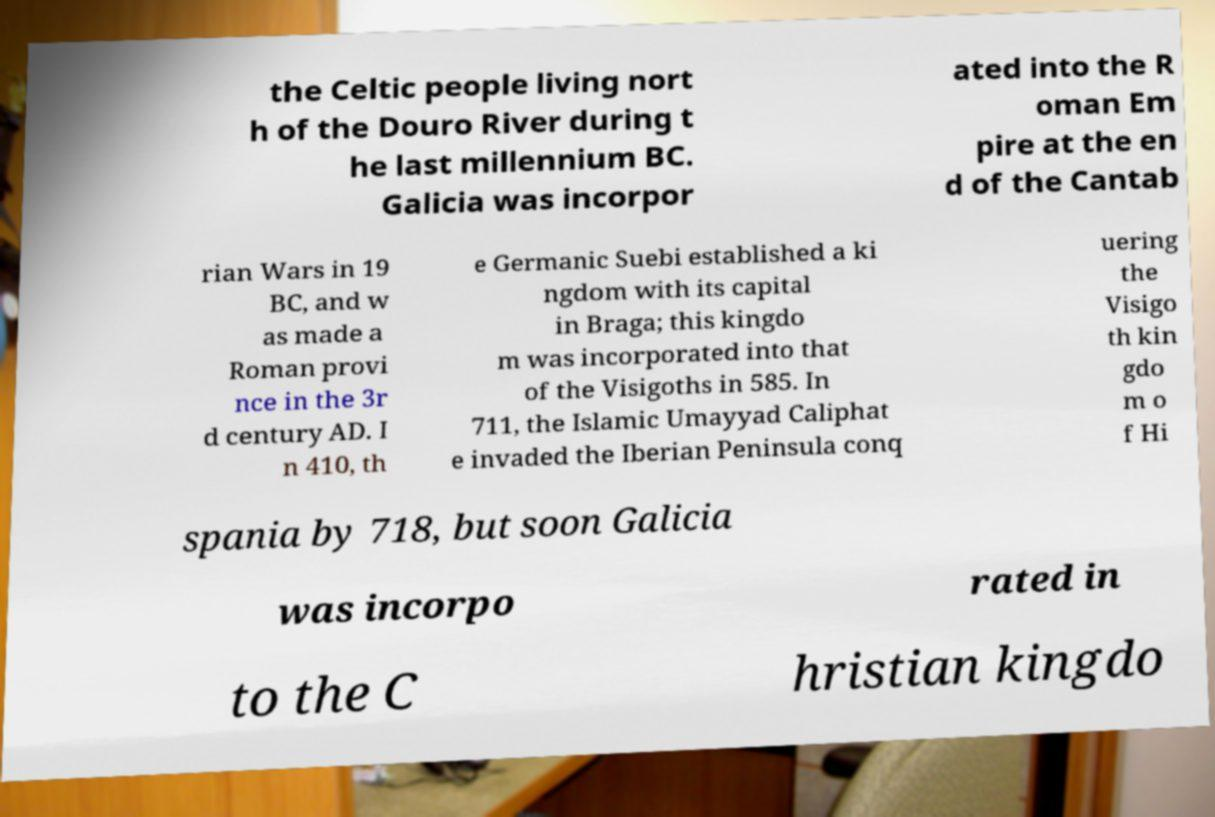Please read and relay the text visible in this image. What does it say? the Celtic people living nort h of the Douro River during t he last millennium BC. Galicia was incorpor ated into the R oman Em pire at the en d of the Cantab rian Wars in 19 BC, and w as made a Roman provi nce in the 3r d century AD. I n 410, th e Germanic Suebi established a ki ngdom with its capital in Braga; this kingdo m was incorporated into that of the Visigoths in 585. In 711, the Islamic Umayyad Caliphat e invaded the Iberian Peninsula conq uering the Visigo th kin gdo m o f Hi spania by 718, but soon Galicia was incorpo rated in to the C hristian kingdo 